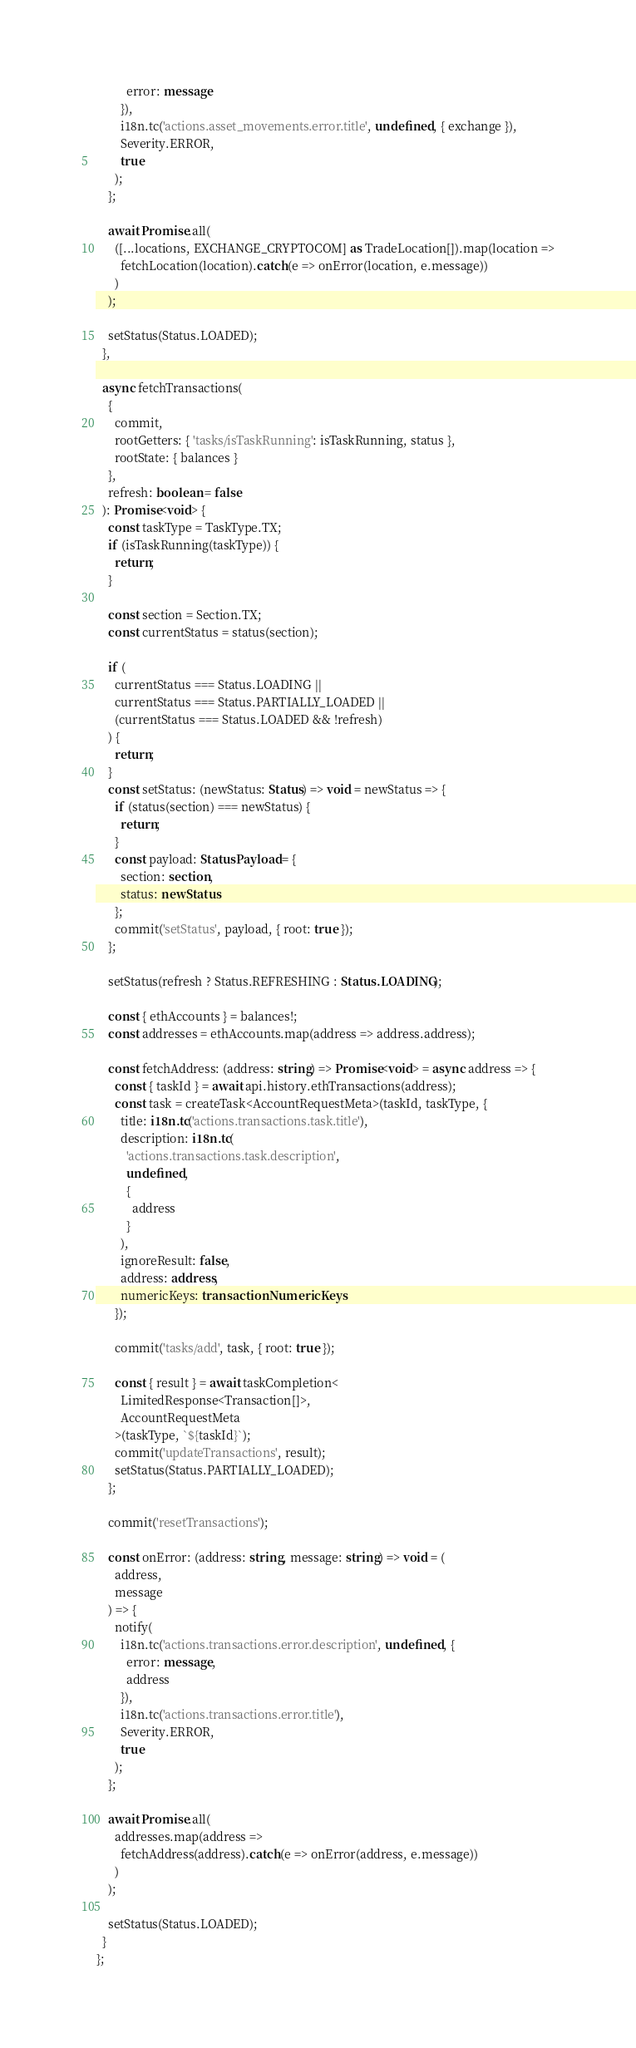<code> <loc_0><loc_0><loc_500><loc_500><_TypeScript_>          error: message
        }),
        i18n.tc('actions.asset_movements.error.title', undefined, { exchange }),
        Severity.ERROR,
        true
      );
    };

    await Promise.all(
      ([...locations, EXCHANGE_CRYPTOCOM] as TradeLocation[]).map(location =>
        fetchLocation(location).catch(e => onError(location, e.message))
      )
    );

    setStatus(Status.LOADED);
  },

  async fetchTransactions(
    {
      commit,
      rootGetters: { 'tasks/isTaskRunning': isTaskRunning, status },
      rootState: { balances }
    },
    refresh: boolean = false
  ): Promise<void> {
    const taskType = TaskType.TX;
    if (isTaskRunning(taskType)) {
      return;
    }

    const section = Section.TX;
    const currentStatus = status(section);

    if (
      currentStatus === Status.LOADING ||
      currentStatus === Status.PARTIALLY_LOADED ||
      (currentStatus === Status.LOADED && !refresh)
    ) {
      return;
    }
    const setStatus: (newStatus: Status) => void = newStatus => {
      if (status(section) === newStatus) {
        return;
      }
      const payload: StatusPayload = {
        section: section,
        status: newStatus
      };
      commit('setStatus', payload, { root: true });
    };

    setStatus(refresh ? Status.REFRESHING : Status.LOADING);

    const { ethAccounts } = balances!;
    const addresses = ethAccounts.map(address => address.address);

    const fetchAddress: (address: string) => Promise<void> = async address => {
      const { taskId } = await api.history.ethTransactions(address);
      const task = createTask<AccountRequestMeta>(taskId, taskType, {
        title: i18n.tc('actions.transactions.task.title'),
        description: i18n.tc(
          'actions.transactions.task.description',
          undefined,
          {
            address
          }
        ),
        ignoreResult: false,
        address: address,
        numericKeys: transactionNumericKeys
      });

      commit('tasks/add', task, { root: true });

      const { result } = await taskCompletion<
        LimitedResponse<Transaction[]>,
        AccountRequestMeta
      >(taskType, `${taskId}`);
      commit('updateTransactions', result);
      setStatus(Status.PARTIALLY_LOADED);
    };

    commit('resetTransactions');

    const onError: (address: string, message: string) => void = (
      address,
      message
    ) => {
      notify(
        i18n.tc('actions.transactions.error.description', undefined, {
          error: message,
          address
        }),
        i18n.tc('actions.transactions.error.title'),
        Severity.ERROR,
        true
      );
    };

    await Promise.all(
      addresses.map(address =>
        fetchAddress(address).catch(e => onError(address, e.message))
      )
    );

    setStatus(Status.LOADED);
  }
};
</code> 